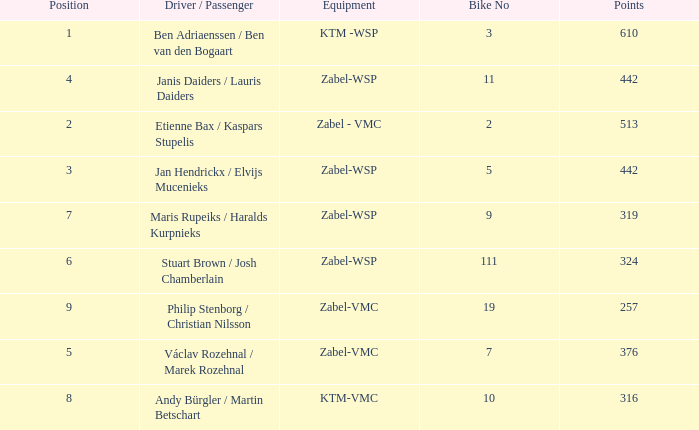What are the points for ktm-vmc equipment?  316.0. 